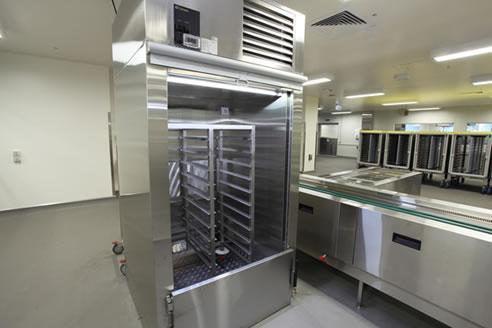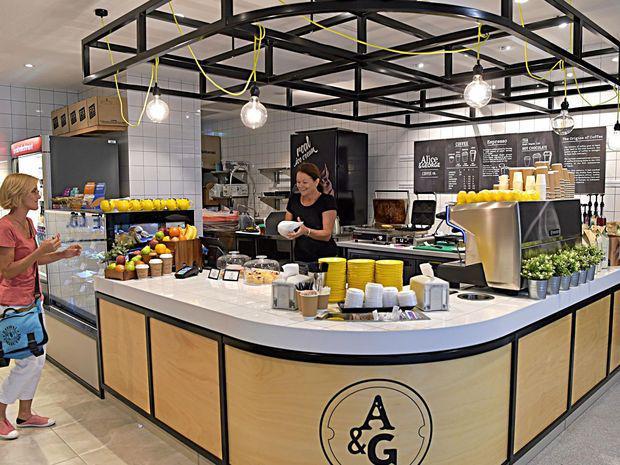The first image is the image on the left, the second image is the image on the right. Assess this claim about the two images: "In at least one image, there is a total of two people.". Correct or not? Answer yes or no. Yes. The first image is the image on the left, the second image is the image on the right. Evaluate the accuracy of this statement regarding the images: "There are people sitting.". Is it true? Answer yes or no. No. 